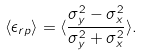Convert formula to latex. <formula><loc_0><loc_0><loc_500><loc_500>\langle \epsilon _ { r p } \rangle = \langle \frac { \sigma _ { y } ^ { 2 } - \sigma _ { x } ^ { 2 } } { \sigma _ { y } ^ { 2 } + \sigma _ { x } ^ { 2 } } \rangle .</formula> 